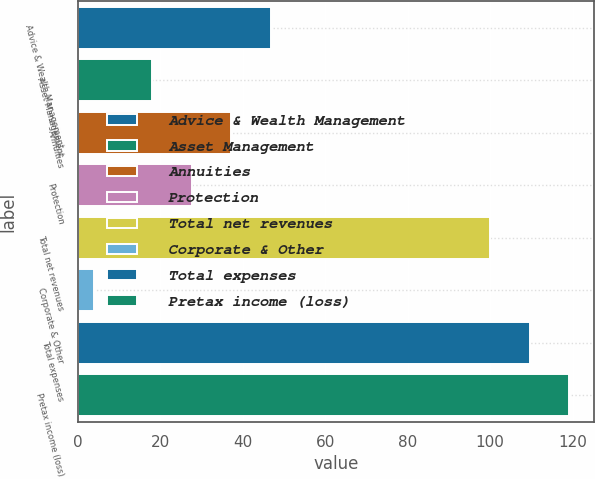Convert chart. <chart><loc_0><loc_0><loc_500><loc_500><bar_chart><fcel>Advice & Wealth Management<fcel>Asset Management<fcel>Annuities<fcel>Protection<fcel>Total net revenues<fcel>Corporate & Other<fcel>Total expenses<fcel>Pretax income (loss)<nl><fcel>46.8<fcel>18<fcel>37.2<fcel>27.6<fcel>100<fcel>4<fcel>109.6<fcel>119.2<nl></chart> 